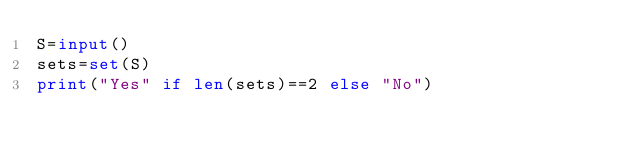<code> <loc_0><loc_0><loc_500><loc_500><_Python_>S=input()
sets=set(S)
print("Yes" if len(sets)==2 else "No")</code> 